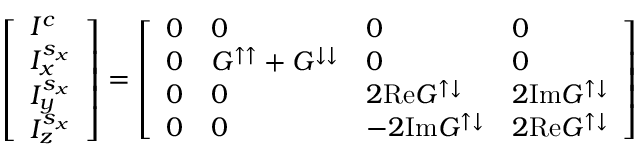Convert formula to latex. <formula><loc_0><loc_0><loc_500><loc_500>\left [ \begin{array} { l } { I ^ { c } } \\ { I _ { x } ^ { s _ { x } } } \\ { I _ { y } ^ { s _ { x } } } \\ { I _ { z } ^ { s _ { x } } } \end{array} \right ] = \left [ \begin{array} { l l l l } { 0 } & { 0 } & { 0 } & { 0 } \\ { 0 } & { G ^ { \uparrow \uparrow } + G ^ { \downarrow \downarrow } } & { 0 } & { 0 } \\ { 0 } & { 0 } & { 2 R e G ^ { \uparrow \downarrow } } & { 2 I m G ^ { \uparrow \downarrow } } \\ { 0 } & { 0 } & { - 2 I m G ^ { \uparrow \downarrow } } & { 2 R e G ^ { \uparrow \downarrow } } \end{array} \right ]</formula> 